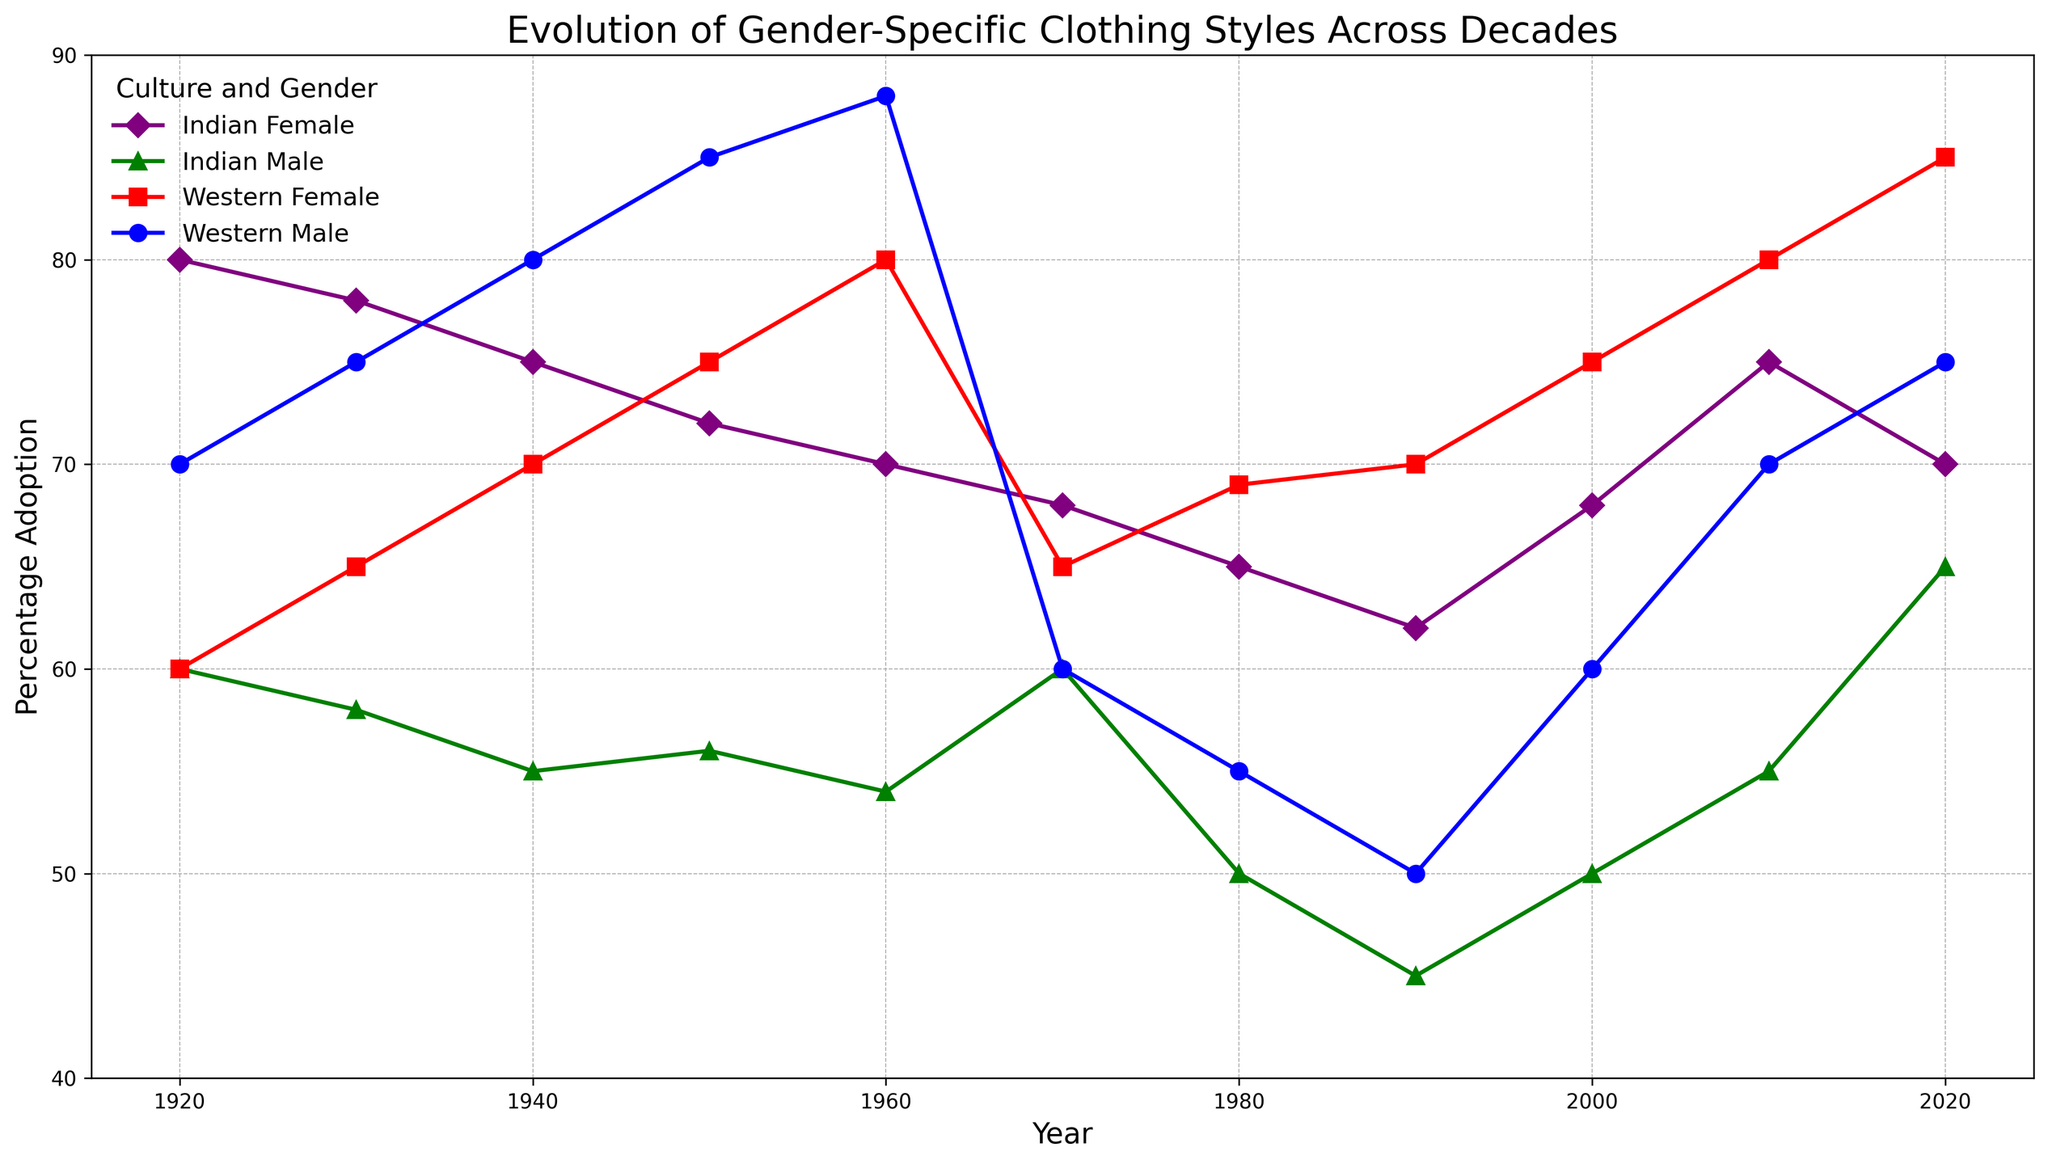What is the trend in the adoption percentage of the Western male clothing styles from 1920 to 2020? Starting from 1920 with a 70% adoption, the trend generally shows minor fluctuations with a peak in the 1960s at 88% before an overall decline to 55% in the 1980s, followed by a steady rise to 75% by 2020
Answer: Overall increase with fluctuations Which cultural and gender-specific clothing saw the highest percentage adoption across all decades? By examining all the lines on the chart and their maxima, the Western Female clothing in 2020 (Athleisure) reaches the highest percentage adoption at 85%
Answer: Western Female (Athleisure) Between Indian females and Western females, which group showed more stable adoption percentages from 1920 to 2020? The Indian female adoption percentages of the sari and later salwar kameez show gradual fluctuations between 80% to 62%, whereas the variations in Western females' styles are more pronounced with larger fluctuations between 60% to 85%
Answer: Indian Females What is the average percentage adoption for Indian male clothing styles from 1920 to 2020? To find the average, sum all given percentages (60+58+55+56+54+60+50+45+50+55+65 = 608) and divide by the number of data points (11), resulting in an approximate average of 55.27
Answer: approx. 55.27 Which gender, across both cultures, experienced the highest rate of increase in clothing style adoption from 2000 to 2020? Calculate the rate difference for each gender: Western Male (70-60=10%), Western Female (85-75=10%), Indian Male (65-50=15%), Indian Female (70-68=2%). The highest increase is seen in Indian Male
Answer: Indian Male By how much did the adoption of Western female clothing styles increase from the 1960s to the 2020s compared to the Indian female clothing styles? Western Female: 85% (2020) - 80% (1960) = 5%, Indian Female: 70% (2020) - 70% (1960) = 0%. Hence, Western female clothing styles increased by 5% more as compared to Indian female styles
Answer: 5% Which year saw the closest adoption percentage between Indian male and female clothing styles, and what was the difference? In the year 1980, both Indian male (50%) and female (65%) adoption styles are closest with a difference of 15%
Answer: 1980, 15% What is the most notable visual change in clothing styles for Western men from 1960 to 1980? There is a significant visual drop in the trend from a high adoption of 88% in 1960 to just 55% in 1980, indicating a major shift or decline in adoption
Answer: Major drop in adoption (88% to 55%) 